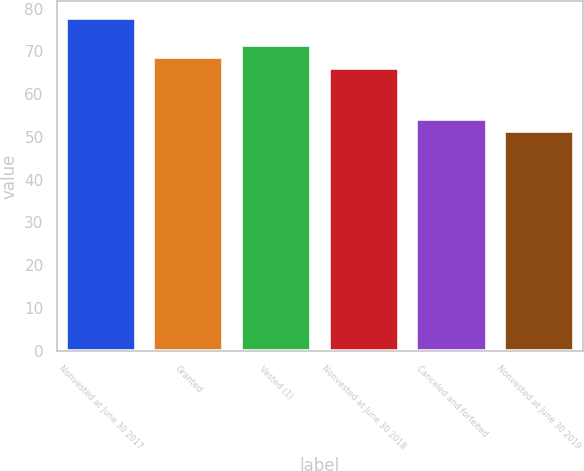Convert chart. <chart><loc_0><loc_0><loc_500><loc_500><bar_chart><fcel>Nonvested at June 30 2017<fcel>Granted<fcel>Vested (1)<fcel>Nonvested at June 30 2018<fcel>Canceled and forfeited<fcel>Nonvested at June 30 2019<nl><fcel>77.83<fcel>68.77<fcel>71.57<fcel>66.13<fcel>54.09<fcel>51.45<nl></chart> 